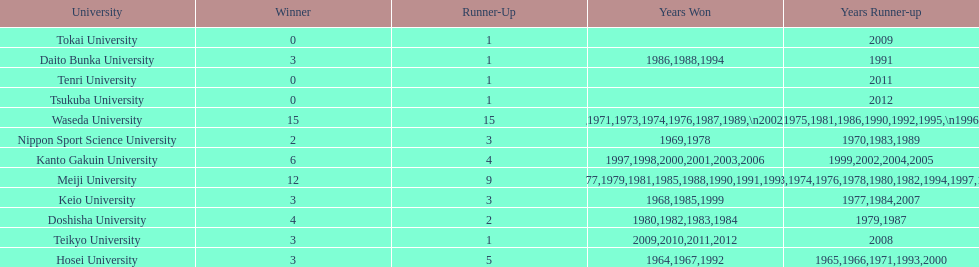Give me the full table as a dictionary. {'header': ['University', 'Winner', 'Runner-Up', 'Years Won', 'Years Runner-up'], 'rows': [['Tokai University', '0', '1', '', '2009'], ['Daito Bunka University', '3', '1', '1986,1988,1994', '1991'], ['Tenri University', '0', '1', '', '2011'], ['Tsukuba University', '0', '1', '', '2012'], ['Waseda University', '15', '15', '1965,1966,1968,1970,1971,1973,1974,1976,1987,1989,\\n2002,2004,2005,2007,2008', '1964,1967,1969,1972,1975,1981,1986,1990,1992,1995,\\n1996,2001,2003,2006,2010'], ['Nippon Sport Science University', '2', '3', '1969,1978', '1970,1983,1989'], ['Kanto Gakuin University', '6', '4', '1997,1998,2000,2001,2003,2006', '1999,2002,2004,2005'], ['Meiji University', '12', '9', '1972,1975,1977,1979,1981,1985,1988,1990,1991,1993,\\n1995,1996', '1973,1974,1976,1978,1980,1982,1994,1997,1998'], ['Keio University', '3', '3', '1968,1985,1999', '1977,1984,2007'], ['Doshisha University', '4', '2', '1980,1982,1983,1984', '1979,1987'], ['Teikyo University', '3', '1', '2009,2010,2011,2012', '2008'], ['Hosei University', '3', '5', '1964,1967,1992', '1965,1966,1971,1993,2000']]} How many championships does nippon sport science university have 2. 